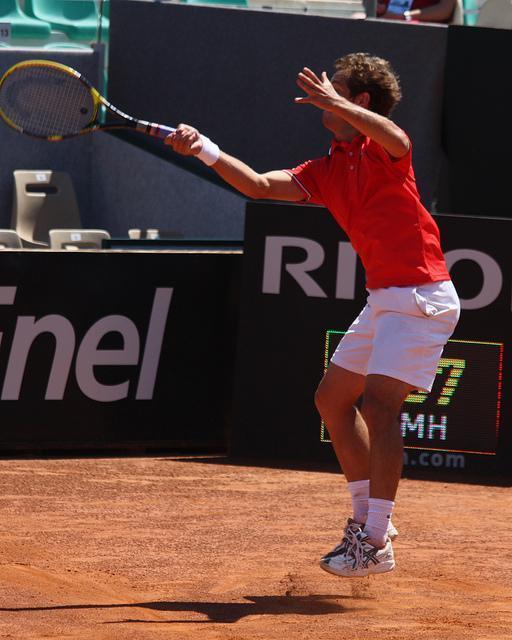How many chairs are there?
Give a very brief answer. 2. 